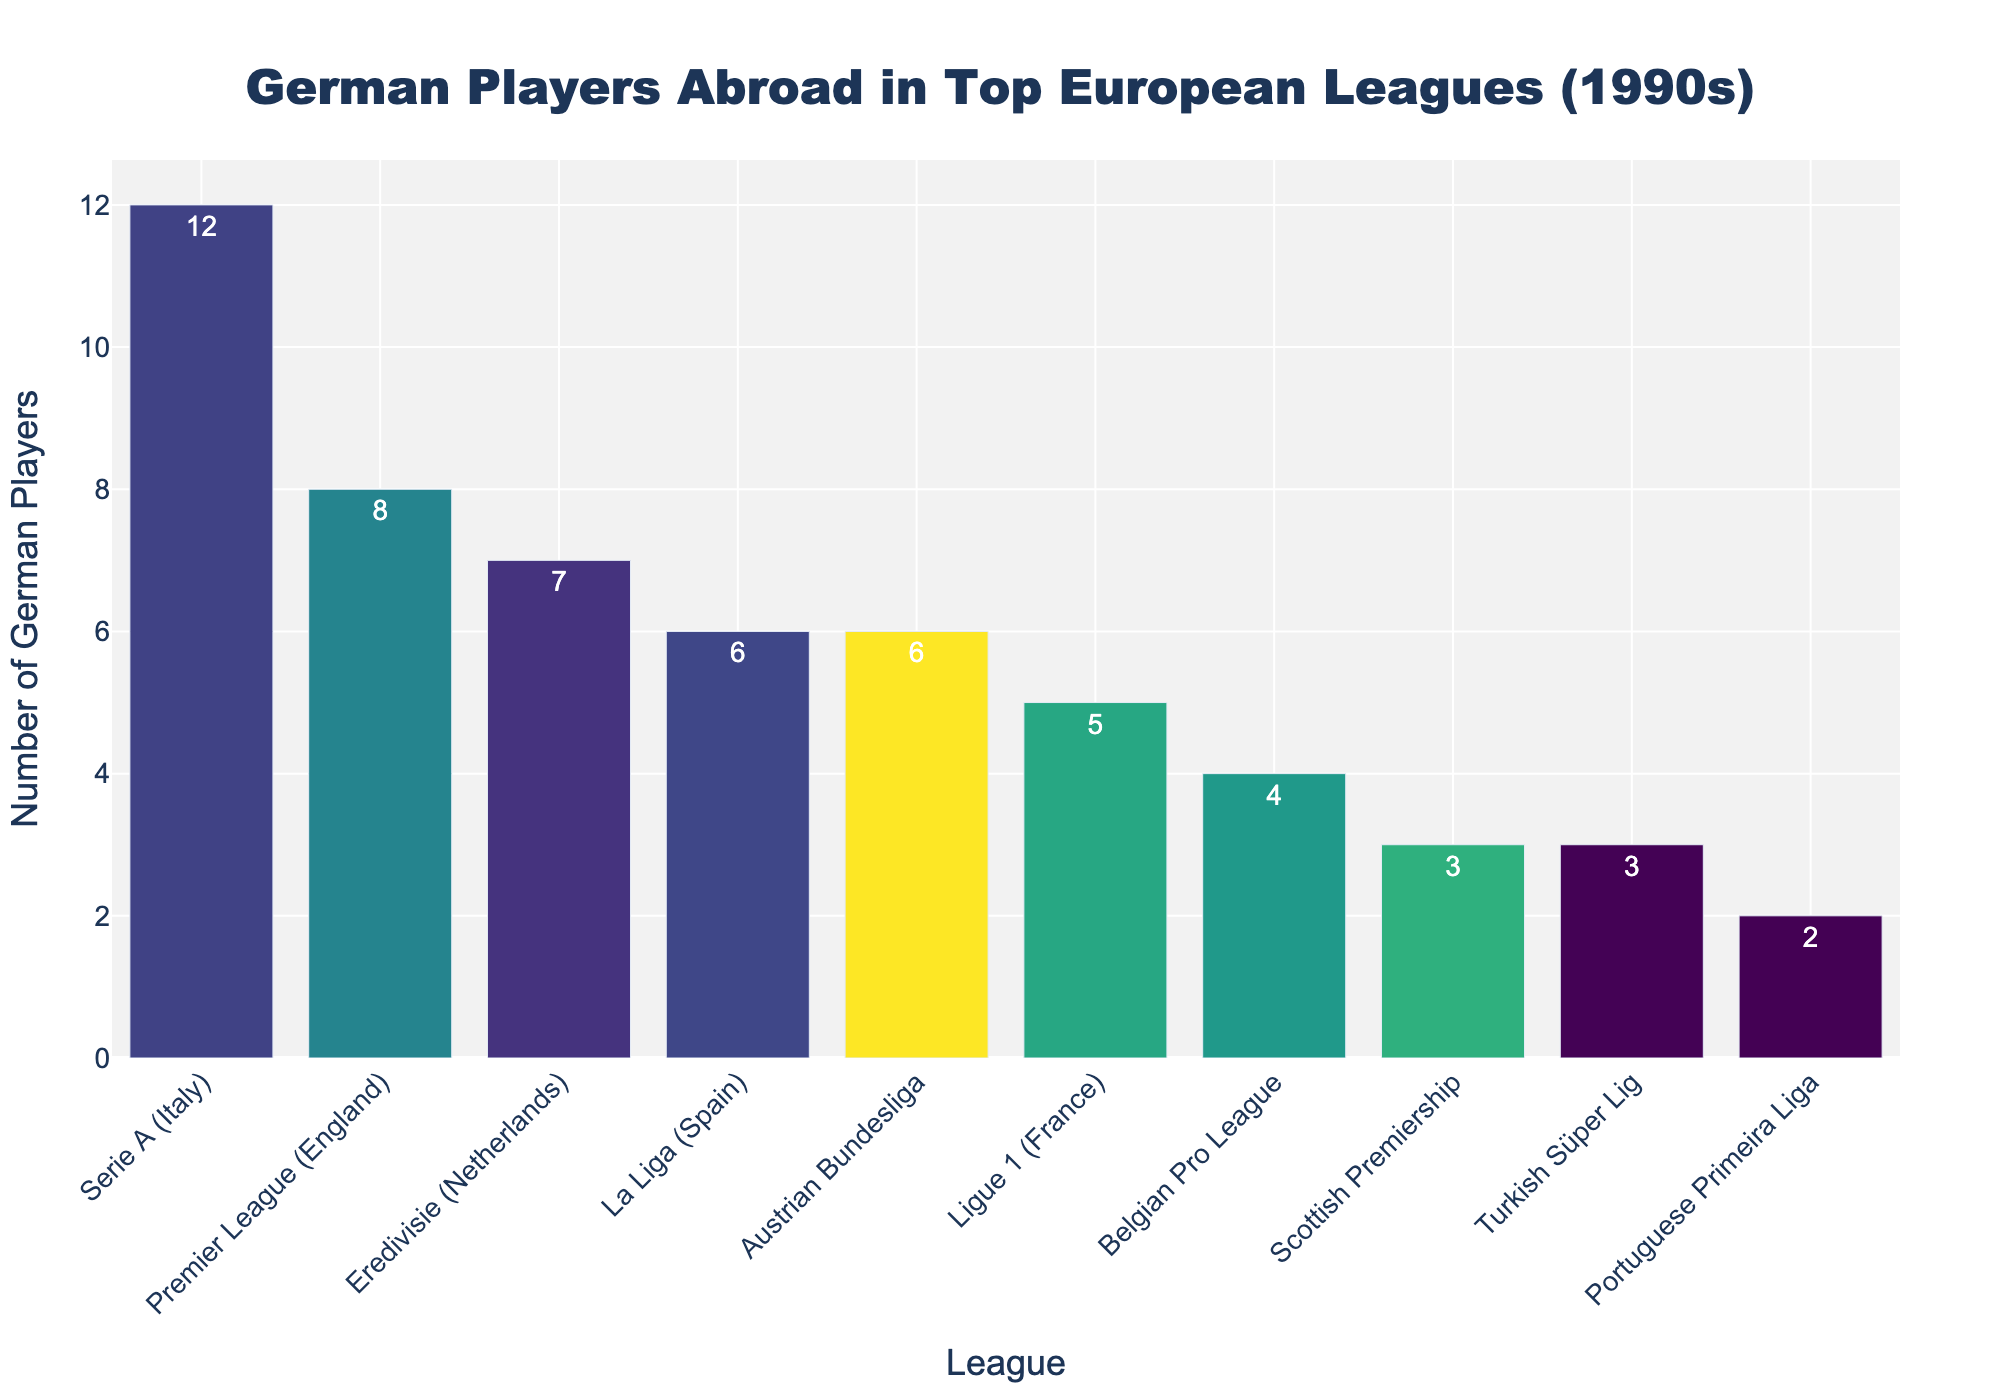Which league had the highest number of German players during the 1990s? The bar chart shows that Serie A (Italy) has the tallest bar, indicating the highest number of German players.
Answer: Serie A (Italy) Which two leagues had the lowest number of German players, and what's their total number? The chart shows the shortest bars for the Portuguese Primeira Liga and the Scottish Premiership. Adding their values, 2 (Portuguese Primeira Liga) + 3 (Scottish Premiership), gives a total of 5.
Answer: Portuguese Primeira Liga and Scottish Premiership; 5 What is the difference in the number of German players between the Eredivisie and La Liga? The chart shows 7 German players in the Eredivisie and 6 in La Liga. Subtracting these values, 7 - 6, gives a difference of 1.
Answer: 1 How many German players were there in the Ligue 1 and Belgian Pro League combined? The chart shows 5 German players in Ligue 1 and 4 in the Belgian Pro League. Adding these values, 5 + 4, gives a total of 9.
Answer: 9 Which leagues had more than 6 German players? The chart shows that Serie A, Premier League, and Eredivisie have bars with heights greater than 6.
Answer: Serie A, Premier League, Eredivisie What is the average number of German players in the Premier League, Ligue 1, and Scottish Premiership? The chart shows 8 German players in the Premier League, 5 in Ligue 1, and 3 in the Scottish Premiership. Adding these values and dividing by 3, (8 + 5 + 3)/3, gives an average of 16/3 = 5.33.
Answer: 5.33 If you add the number of German players in Serie A and La Liga, do they exceed the combined number in the Premier League and Eredivisie? Serie A has 12 and La Liga has 6 German players, summing to 18. The Premier League has 8 and Eredivisie has 7, summing to 15. Comparing these sums, 18 is greater than 15.
Answer: Yes Which league had exactly half the number of German players as the Serie A? Serie A has 12 German players. The chart shows that Ligue 1 had 6 German players, exactly half of 12.
Answer: Ligue 1 What is the combined number of German players in the Austrian Bundesliga and Turkish Süper Lig? The chart shows 6 German players in the Austrian Bundesliga and 3 in the Turkish Süper Lig. Adding these values, 6 + 3, gives a total of 9.
Answer: 9 